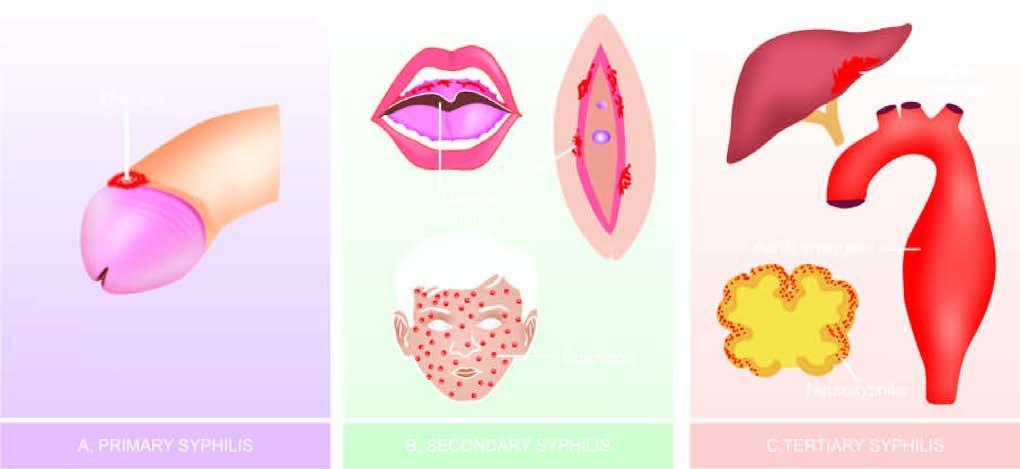what is 'chancre ' on glans penis?
Answer the question using a single word or phrase. Primary lesion 